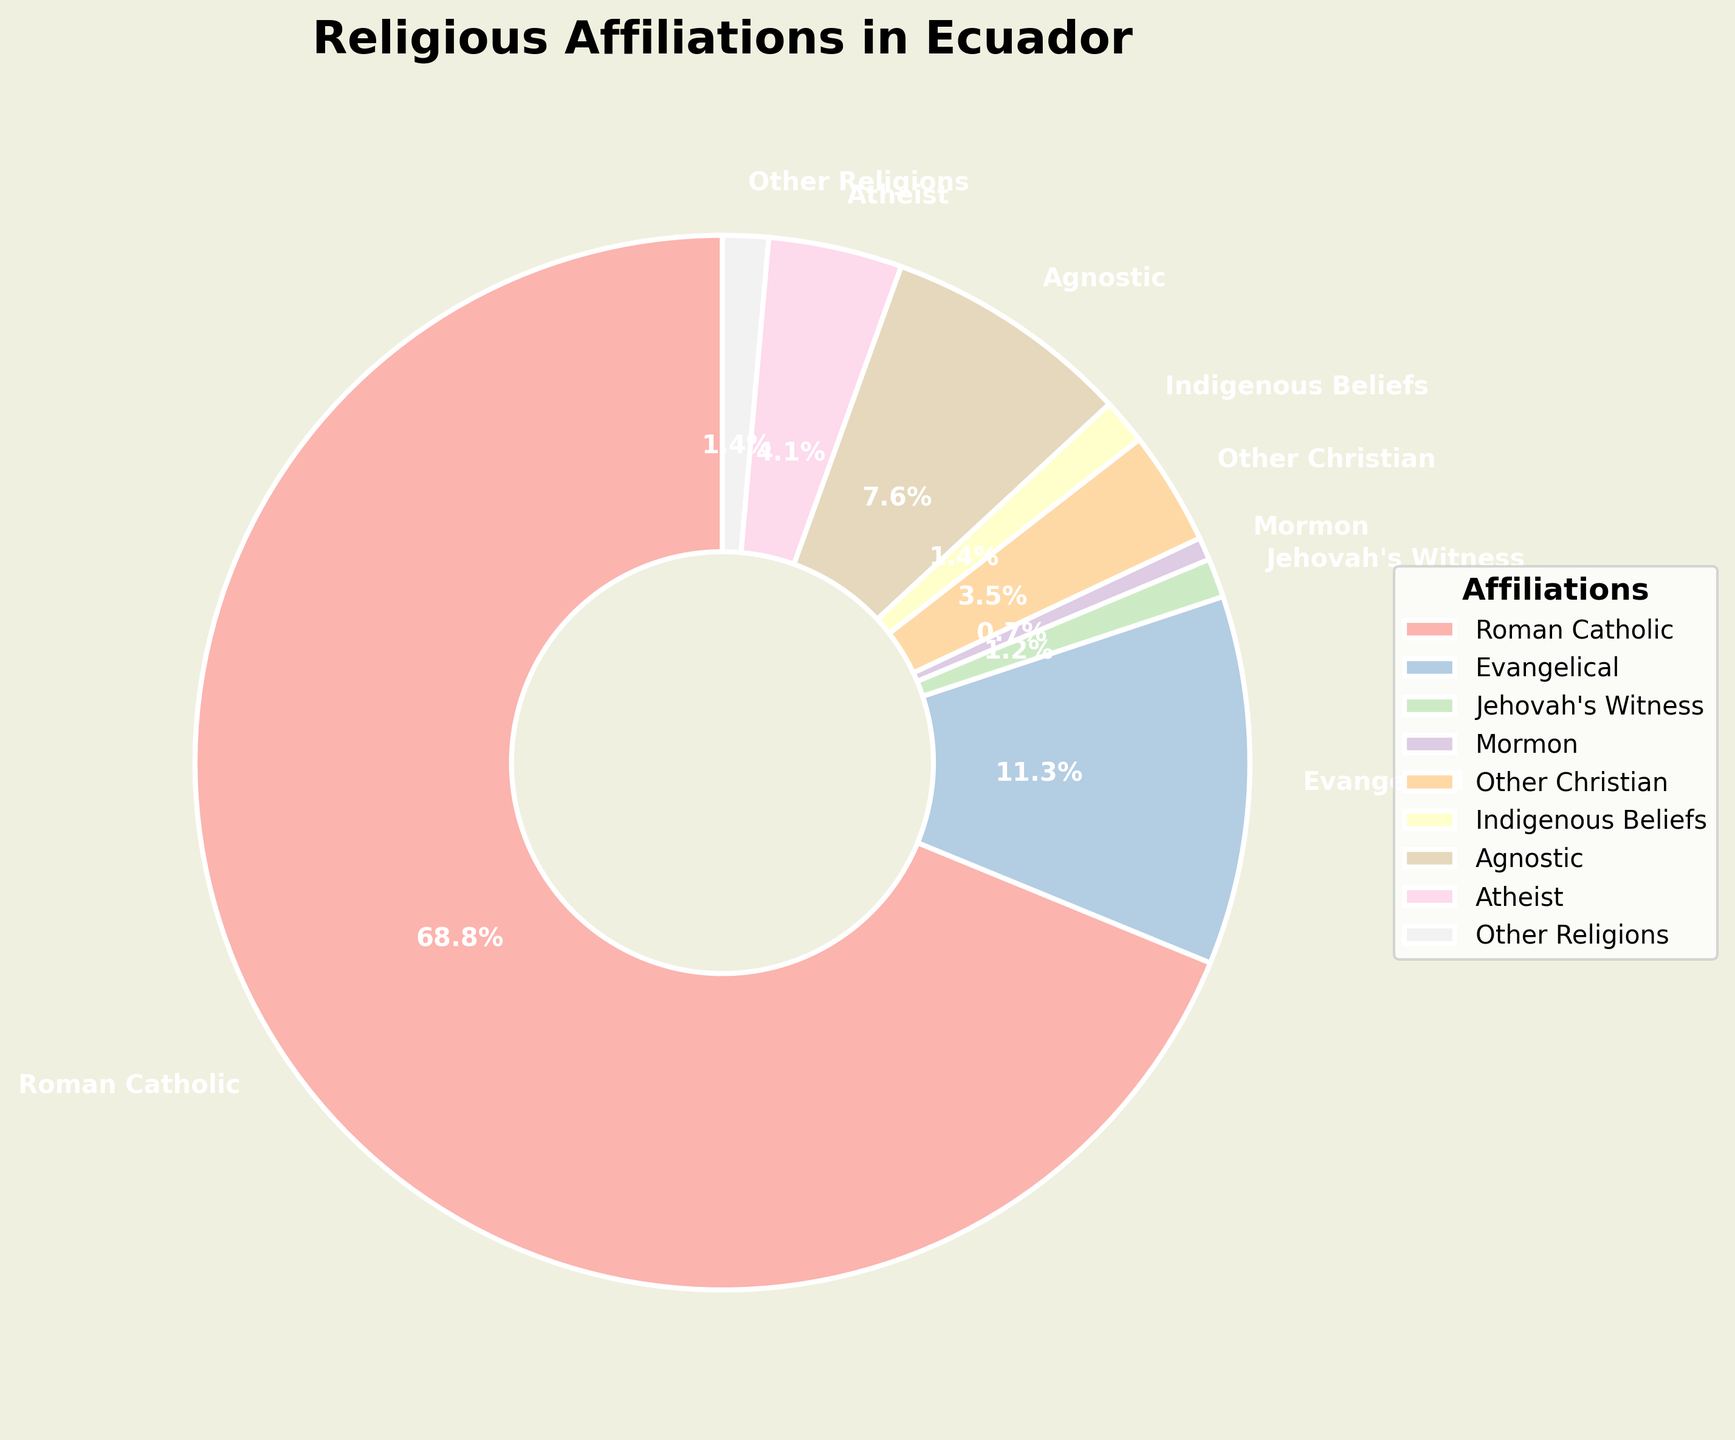What percentage of Ecuadorians identify as either Roman Catholic or Evangelical? Add the percentages for Roman Catholic (68.8%) and Evangelical (11.3%). The sum is 68.8 + 11.3 = 80.1%
Answer: 80.1% Which religious affiliation has the smallest percentage? Look for the smallest percentage in the chart, which is Mormon with 0.7%
Answer: Mormon Is the percentage of atheists greater than that of agnostics? Compare the percentages: 4.1% for Atheists and 7.6% for Agnostics. Since 4.1 is less than 7.6, the answer is no
Answer: No How much higher is the percentage of Roman Catholics compared to the combined percentage of Atheists and Agnostics? Difference between Roman Catholics (68.8%) and the combined percentage of Atheists (4.1%) and Agnostics (7.6%), which is 4.1 + 7.6 = 11.7%. So, 68.8 - 11.7 = 57.1%
Answer: 57.1% What is the combined percentage of all Christian denominations excluding Roman Catholic? Add the percentages for Evangelical (11.3%), Jehovah's Witness (1.2%), Mormon (0.7%), and Other Christian (3.5%). The sum is 11.3 + 1.2 + 0.7 + 3.5 = 16.7%
Answer: 16.7% Which religious affiliation is represented by the largest wedge in the pie chart? Look for the largest segment in the pie chart, which represents Roman Catholic with 68.8%
Answer: Roman Catholic Do the combined percentages of Other Religions and Indigenous Beliefs exceed that of Evangelical? Add the percentages of Other Religions (1.4%) and Indigenous Beliefs (1.4%), which is 1.4 + 1.4 = 2.8%. Compare this with Evangelical's 11.3%, so 2.8 is less than 11.3%
Answer: No Which colors represent the Roman Catholic and Evangelical segments in the pie chart? Identify the colors used for Roman Catholic and Evangelical segments, which can be seen as distinct pastel shades in the chart
Answer: [Visual attribute, answer varies] Among the non-religious categories (Agnostic and Atheist), which is more prevalent? Compare the percentages: Agnostic (7.6%) and Atheist (4.1%). Since 7.6 is greater than 4.1, Agnostic is more prevalent
Answer: Agnostic Is the percentage of Indigenous Beliefs equal to that of Other Religions? Compare the percentages: Indigenous Beliefs (1.4%) and Other Religions (1.4%). Since both are equal, the answer is yes
Answer: Yes 